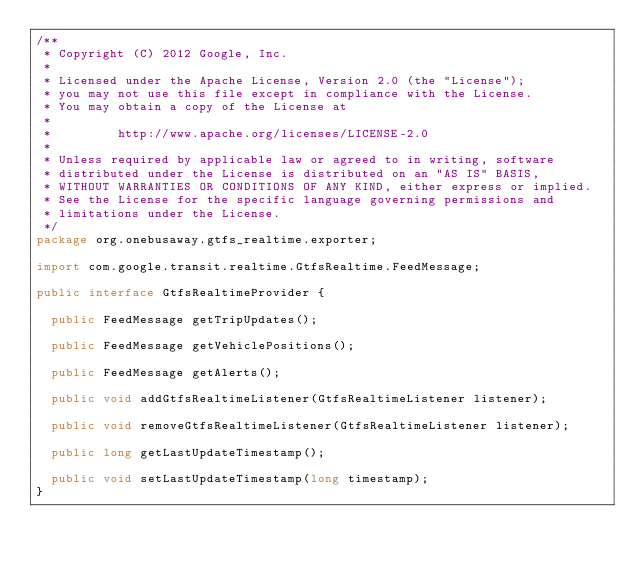<code> <loc_0><loc_0><loc_500><loc_500><_Java_>/**
 * Copyright (C) 2012 Google, Inc.
 *
 * Licensed under the Apache License, Version 2.0 (the "License");
 * you may not use this file except in compliance with the License.
 * You may obtain a copy of the License at
 *
 *         http://www.apache.org/licenses/LICENSE-2.0
 *
 * Unless required by applicable law or agreed to in writing, software
 * distributed under the License is distributed on an "AS IS" BASIS,
 * WITHOUT WARRANTIES OR CONDITIONS OF ANY KIND, either express or implied.
 * See the License for the specific language governing permissions and
 * limitations under the License.
 */
package org.onebusaway.gtfs_realtime.exporter;

import com.google.transit.realtime.GtfsRealtime.FeedMessage;

public interface GtfsRealtimeProvider {
  
  public FeedMessage getTripUpdates();

  public FeedMessage getVehiclePositions();

  public FeedMessage getAlerts();
  
  public void addGtfsRealtimeListener(GtfsRealtimeListener listener);
  
  public void removeGtfsRealtimeListener(GtfsRealtimeListener listener);

  public long getLastUpdateTimestamp();

  public void setLastUpdateTimestamp(long timestamp);
}
</code> 